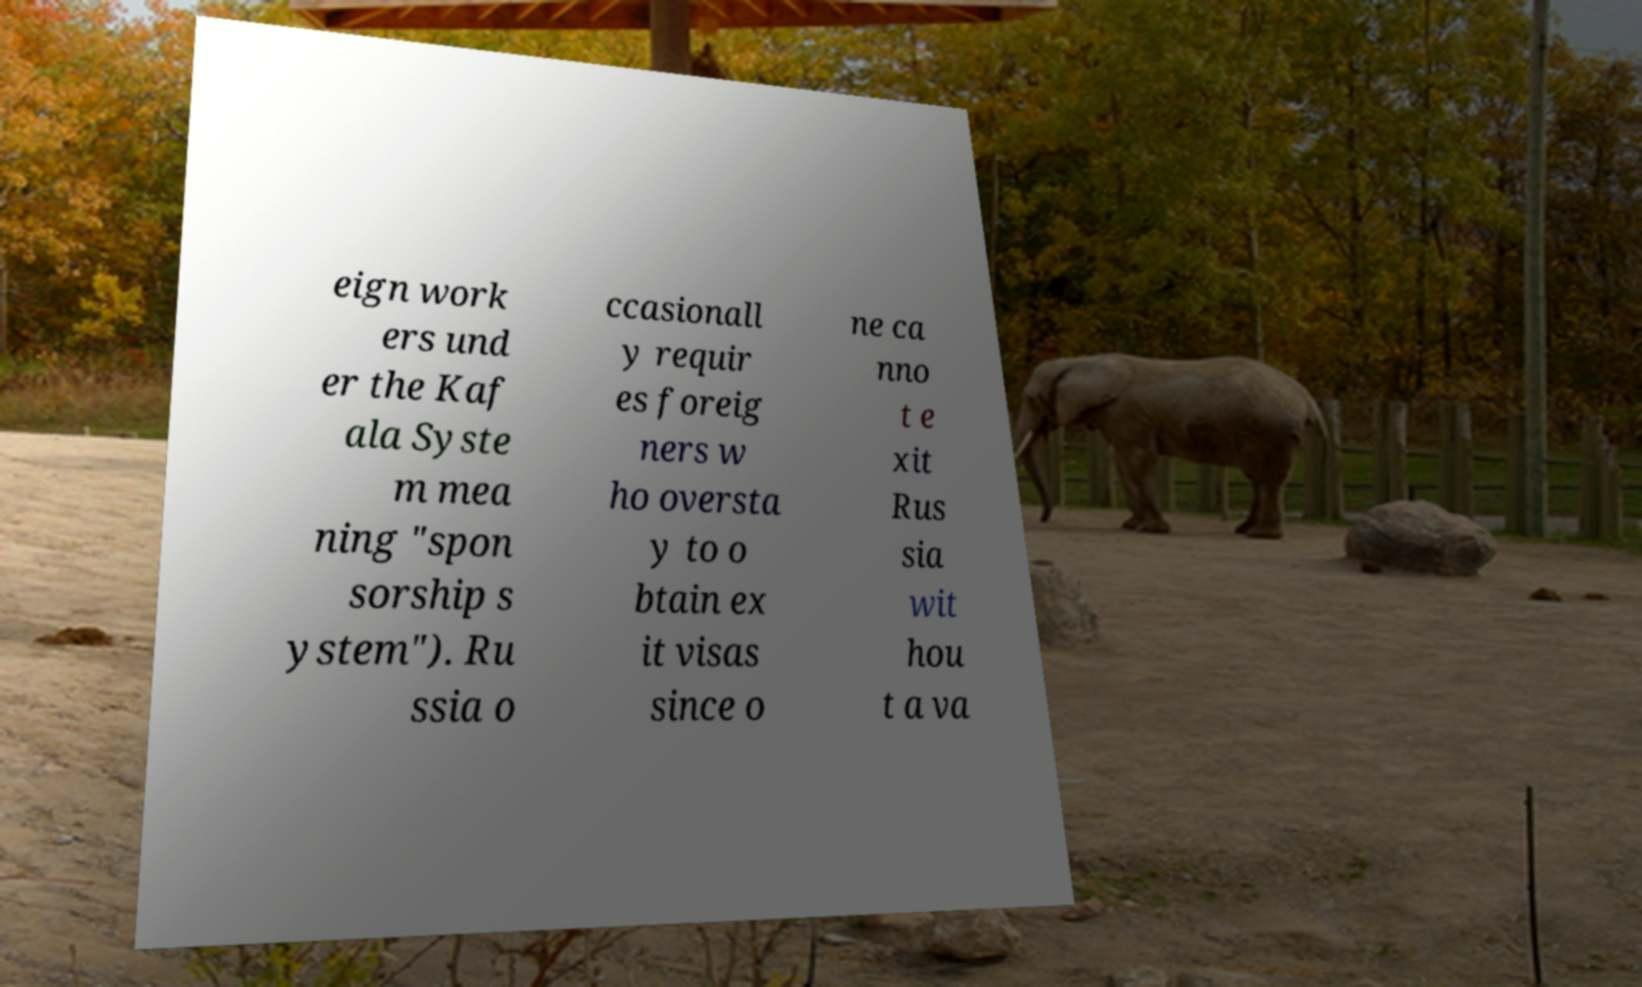There's text embedded in this image that I need extracted. Can you transcribe it verbatim? eign work ers und er the Kaf ala Syste m mea ning "spon sorship s ystem"). Ru ssia o ccasionall y requir es foreig ners w ho oversta y to o btain ex it visas since o ne ca nno t e xit Rus sia wit hou t a va 